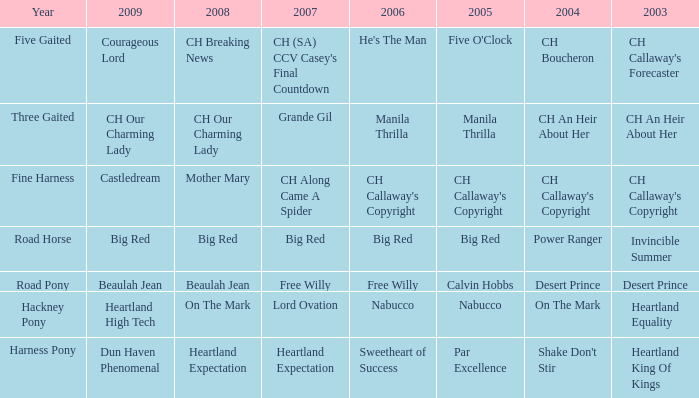What year is the 2007 big red? Road Horse. 